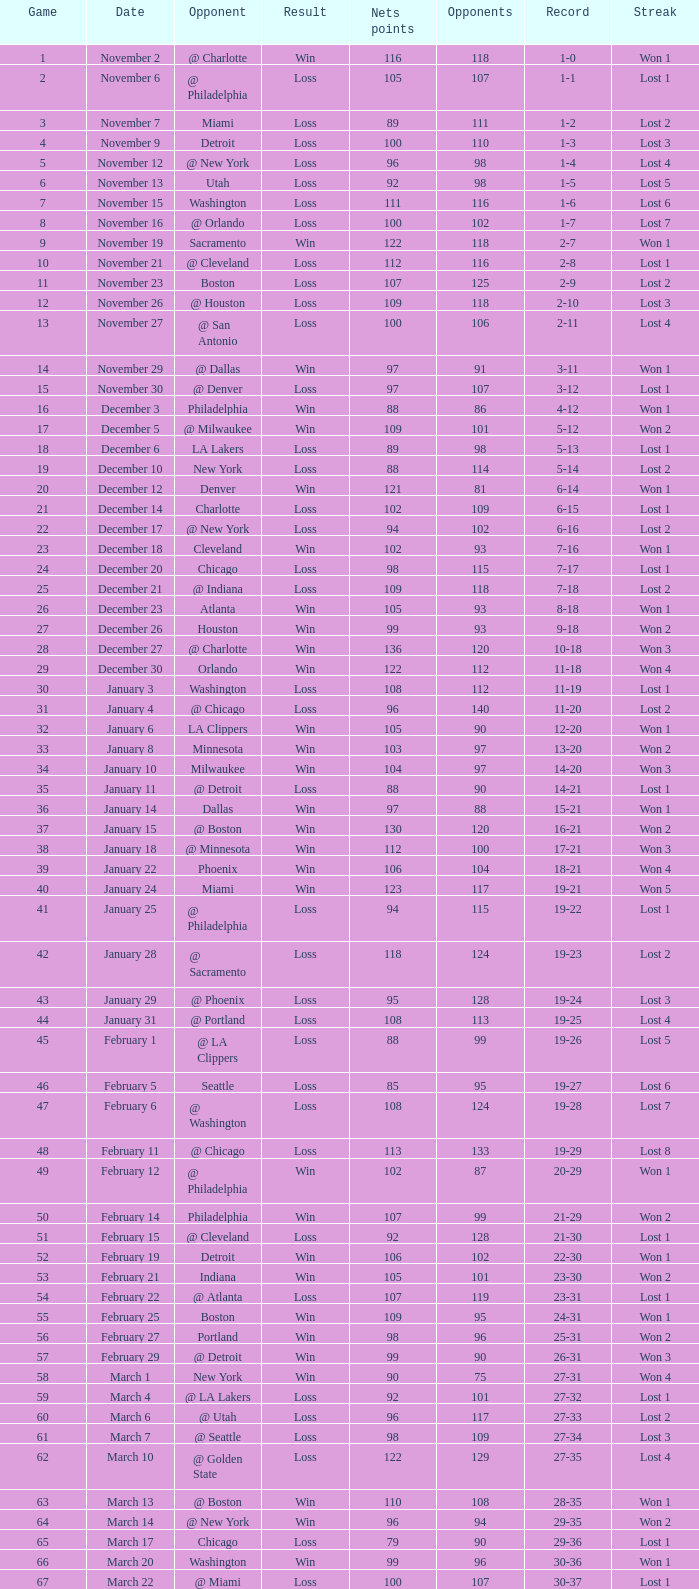Can you parse all the data within this table? {'header': ['Game', 'Date', 'Opponent', 'Result', 'Nets points', 'Opponents', 'Record', 'Streak'], 'rows': [['1', 'November 2', '@ Charlotte', 'Win', '116', '118', '1-0', 'Won 1'], ['2', 'November 6', '@ Philadelphia', 'Loss', '105', '107', '1-1', 'Lost 1'], ['3', 'November 7', 'Miami', 'Loss', '89', '111', '1-2', 'Lost 2'], ['4', 'November 9', 'Detroit', 'Loss', '100', '110', '1-3', 'Lost 3'], ['5', 'November 12', '@ New York', 'Loss', '96', '98', '1-4', 'Lost 4'], ['6', 'November 13', 'Utah', 'Loss', '92', '98', '1-5', 'Lost 5'], ['7', 'November 15', 'Washington', 'Loss', '111', '116', '1-6', 'Lost 6'], ['8', 'November 16', '@ Orlando', 'Loss', '100', '102', '1-7', 'Lost 7'], ['9', 'November 19', 'Sacramento', 'Win', '122', '118', '2-7', 'Won 1'], ['10', 'November 21', '@ Cleveland', 'Loss', '112', '116', '2-8', 'Lost 1'], ['11', 'November 23', 'Boston', 'Loss', '107', '125', '2-9', 'Lost 2'], ['12', 'November 26', '@ Houston', 'Loss', '109', '118', '2-10', 'Lost 3'], ['13', 'November 27', '@ San Antonio', 'Loss', '100', '106', '2-11', 'Lost 4'], ['14', 'November 29', '@ Dallas', 'Win', '97', '91', '3-11', 'Won 1'], ['15', 'November 30', '@ Denver', 'Loss', '97', '107', '3-12', 'Lost 1'], ['16', 'December 3', 'Philadelphia', 'Win', '88', '86', '4-12', 'Won 1'], ['17', 'December 5', '@ Milwaukee', 'Win', '109', '101', '5-12', 'Won 2'], ['18', 'December 6', 'LA Lakers', 'Loss', '89', '98', '5-13', 'Lost 1'], ['19', 'December 10', 'New York', 'Loss', '88', '114', '5-14', 'Lost 2'], ['20', 'December 12', 'Denver', 'Win', '121', '81', '6-14', 'Won 1'], ['21', 'December 14', 'Charlotte', 'Loss', '102', '109', '6-15', 'Lost 1'], ['22', 'December 17', '@ New York', 'Loss', '94', '102', '6-16', 'Lost 2'], ['23', 'December 18', 'Cleveland', 'Win', '102', '93', '7-16', 'Won 1'], ['24', 'December 20', 'Chicago', 'Loss', '98', '115', '7-17', 'Lost 1'], ['25', 'December 21', '@ Indiana', 'Loss', '109', '118', '7-18', 'Lost 2'], ['26', 'December 23', 'Atlanta', 'Win', '105', '93', '8-18', 'Won 1'], ['27', 'December 26', 'Houston', 'Win', '99', '93', '9-18', 'Won 2'], ['28', 'December 27', '@ Charlotte', 'Win', '136', '120', '10-18', 'Won 3'], ['29', 'December 30', 'Orlando', 'Win', '122', '112', '11-18', 'Won 4'], ['30', 'January 3', 'Washington', 'Loss', '108', '112', '11-19', 'Lost 1'], ['31', 'January 4', '@ Chicago', 'Loss', '96', '140', '11-20', 'Lost 2'], ['32', 'January 6', 'LA Clippers', 'Win', '105', '90', '12-20', 'Won 1'], ['33', 'January 8', 'Minnesota', 'Win', '103', '97', '13-20', 'Won 2'], ['34', 'January 10', 'Milwaukee', 'Win', '104', '97', '14-20', 'Won 3'], ['35', 'January 11', '@ Detroit', 'Loss', '88', '90', '14-21', 'Lost 1'], ['36', 'January 14', 'Dallas', 'Win', '97', '88', '15-21', 'Won 1'], ['37', 'January 15', '@ Boston', 'Win', '130', '120', '16-21', 'Won 2'], ['38', 'January 18', '@ Minnesota', 'Win', '112', '100', '17-21', 'Won 3'], ['39', 'January 22', 'Phoenix', 'Win', '106', '104', '18-21', 'Won 4'], ['40', 'January 24', 'Miami', 'Win', '123', '117', '19-21', 'Won 5'], ['41', 'January 25', '@ Philadelphia', 'Loss', '94', '115', '19-22', 'Lost 1'], ['42', 'January 28', '@ Sacramento', 'Loss', '118', '124', '19-23', 'Lost 2'], ['43', 'January 29', '@ Phoenix', 'Loss', '95', '128', '19-24', 'Lost 3'], ['44', 'January 31', '@ Portland', 'Loss', '108', '113', '19-25', 'Lost 4'], ['45', 'February 1', '@ LA Clippers', 'Loss', '88', '99', '19-26', 'Lost 5'], ['46', 'February 5', 'Seattle', 'Loss', '85', '95', '19-27', 'Lost 6'], ['47', 'February 6', '@ Washington', 'Loss', '108', '124', '19-28', 'Lost 7'], ['48', 'February 11', '@ Chicago', 'Loss', '113', '133', '19-29', 'Lost 8'], ['49', 'February 12', '@ Philadelphia', 'Win', '102', '87', '20-29', 'Won 1'], ['50', 'February 14', 'Philadelphia', 'Win', '107', '99', '21-29', 'Won 2'], ['51', 'February 15', '@ Cleveland', 'Loss', '92', '128', '21-30', 'Lost 1'], ['52', 'February 19', 'Detroit', 'Win', '106', '102', '22-30', 'Won 1'], ['53', 'February 21', 'Indiana', 'Win', '105', '101', '23-30', 'Won 2'], ['54', 'February 22', '@ Atlanta', 'Loss', '107', '119', '23-31', 'Lost 1'], ['55', 'February 25', 'Boston', 'Win', '109', '95', '24-31', 'Won 1'], ['56', 'February 27', 'Portland', 'Win', '98', '96', '25-31', 'Won 2'], ['57', 'February 29', '@ Detroit', 'Win', '99', '90', '26-31', 'Won 3'], ['58', 'March 1', 'New York', 'Win', '90', '75', '27-31', 'Won 4'], ['59', 'March 4', '@ LA Lakers', 'Loss', '92', '101', '27-32', 'Lost 1'], ['60', 'March 6', '@ Utah', 'Loss', '96', '117', '27-33', 'Lost 2'], ['61', 'March 7', '@ Seattle', 'Loss', '98', '109', '27-34', 'Lost 3'], ['62', 'March 10', '@ Golden State', 'Loss', '122', '129', '27-35', 'Lost 4'], ['63', 'March 13', '@ Boston', 'Win', '110', '108', '28-35', 'Won 1'], ['64', 'March 14', '@ New York', 'Win', '96', '94', '29-35', 'Won 2'], ['65', 'March 17', 'Chicago', 'Loss', '79', '90', '29-36', 'Lost 1'], ['66', 'March 20', 'Washington', 'Win', '99', '96', '30-36', 'Won 1'], ['67', 'March 22', '@ Miami', 'Loss', '100', '107', '30-37', 'Lost 1'], ['68', 'March 23', 'Charlotte', 'Win', '123', '120', '31-37', 'Won 1'], ['69', 'March 25', 'Boston', 'Loss', '110', '118', '31-38', 'Lost 1'], ['70', 'March 28', 'Golden State', 'Loss', '148', '153', '31-39', 'Lost 2'], ['71', 'March 30', 'San Antonio', 'Win', '117', '109', '32-39', 'Won 1'], ['72', 'April 1', '@ Milwaukee', 'Win', '121', '117', '33-39', 'Won 2'], ['73', 'April 3', 'Milwaukee', 'Win', '122', '103', '34-39', 'Won 3'], ['74', 'April 5', '@ Indiana', 'Win', '128', '120', '35-39', 'Won 4'], ['75', 'April 7', 'Atlanta', 'Loss', '97', '104', '35-40', 'Lost 1'], ['76', 'April 8', '@ Washington', 'Win', '109', '103', '36-40', 'Won 1'], ['77', 'April 10', 'Cleveland', 'Win', '110', '86', '37-40', 'Won 2'], ['78', 'April 11', '@ Atlanta', 'Loss', '98', '118', '37-41', 'Lost 1'], ['79', 'April 13', '@ Orlando', 'Win', '110', '104', '38-41', 'Won 1'], ['80', 'April 14', '@ Miami', 'Win', '105', '100', '39-41', 'Won 2'], ['81', 'April 16', 'Indiana', 'Loss', '113', '119', '39-42', 'Lost 1'], ['82', 'April 18', 'Orlando', 'Win', '127', '111', '40-42', 'Won 1'], ['1', 'April 23', '@ Cleveland', 'Loss', '113', '120', '0-1', 'Lost 1'], ['2', 'April 25', '@ Cleveland', 'Loss', '96', '118', '0-2', 'Lost 2'], ['3', 'April 28', 'Cleveland', 'Win', '109', '104', '1-2', 'Won 1'], ['4', 'April 30', 'Cleveland', 'Loss', '89', '98', '1-3', 'Lost 1']]} Which opponent is from february 12? @ Philadelphia. 